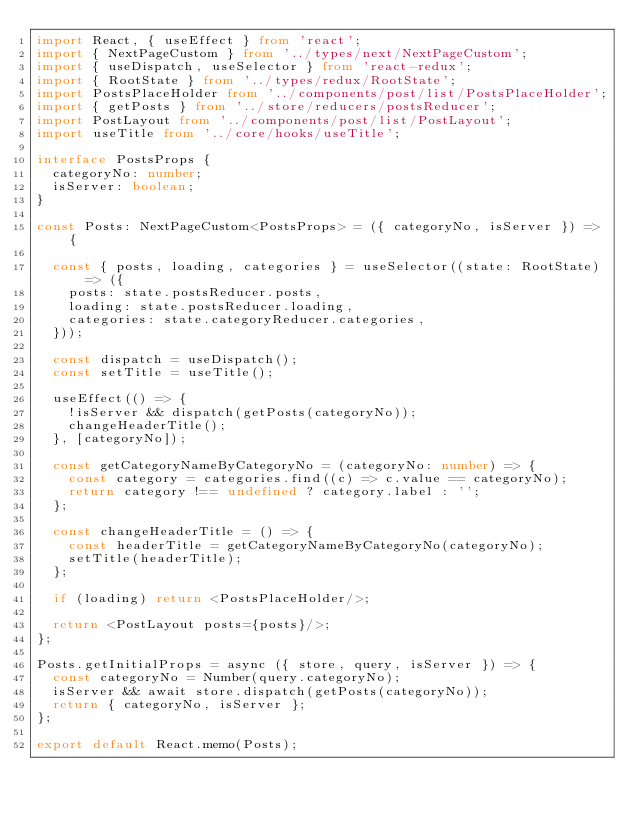<code> <loc_0><loc_0><loc_500><loc_500><_TypeScript_>import React, { useEffect } from 'react';
import { NextPageCustom } from '../types/next/NextPageCustom';
import { useDispatch, useSelector } from 'react-redux';
import { RootState } from '../types/redux/RootState';
import PostsPlaceHolder from '../components/post/list/PostsPlaceHolder';
import { getPosts } from '../store/reducers/postsReducer';
import PostLayout from '../components/post/list/PostLayout';
import useTitle from '../core/hooks/useTitle';

interface PostsProps {
  categoryNo: number;
  isServer: boolean;
}

const Posts: NextPageCustom<PostsProps> = ({ categoryNo, isServer }) => {

  const { posts, loading, categories } = useSelector((state: RootState) => ({
    posts: state.postsReducer.posts,
    loading: state.postsReducer.loading,
    categories: state.categoryReducer.categories,
  }));

  const dispatch = useDispatch();
  const setTitle = useTitle();

  useEffect(() => {
    !isServer && dispatch(getPosts(categoryNo));
    changeHeaderTitle();
  }, [categoryNo]);

  const getCategoryNameByCategoryNo = (categoryNo: number) => {
    const category = categories.find((c) => c.value == categoryNo);
    return category !== undefined ? category.label : '';
  };

  const changeHeaderTitle = () => {
    const headerTitle = getCategoryNameByCategoryNo(categoryNo);
    setTitle(headerTitle);
  };

  if (loading) return <PostsPlaceHolder/>;

  return <PostLayout posts={posts}/>;
};

Posts.getInitialProps = async ({ store, query, isServer }) => {
  const categoryNo = Number(query.categoryNo);
  isServer && await store.dispatch(getPosts(categoryNo));
  return { categoryNo, isServer };
};

export default React.memo(Posts);
</code> 